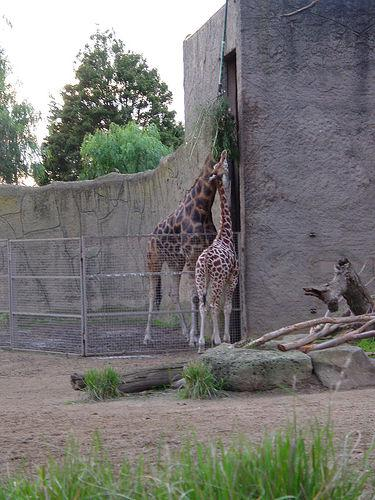Question: where are the giraffes?
Choices:
A. Zoo.
B. In africa.
C. In the wild.
D. In the background.
Answer with the letter. Answer: A Question: how many giraffes are there?
Choices:
A. Three.
B. Four.
C. Five.
D. Two.
Answer with the letter. Answer: D Question: what is on the ground?
Choices:
A. Concrete.
B. Dirt.
C. Rocks.
D. Sand.
Answer with the letter. Answer: C Question: who is with the giraffes?
Choices:
A. The trainer.
B. A hunter.
C. A safari guide.
D. No one.
Answer with the letter. Answer: D 